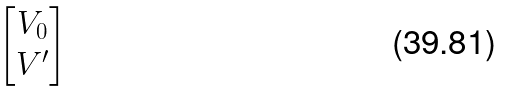Convert formula to latex. <formula><loc_0><loc_0><loc_500><loc_500>\begin{bmatrix} V _ { 0 } \\ V ^ { \prime } \end{bmatrix}</formula> 